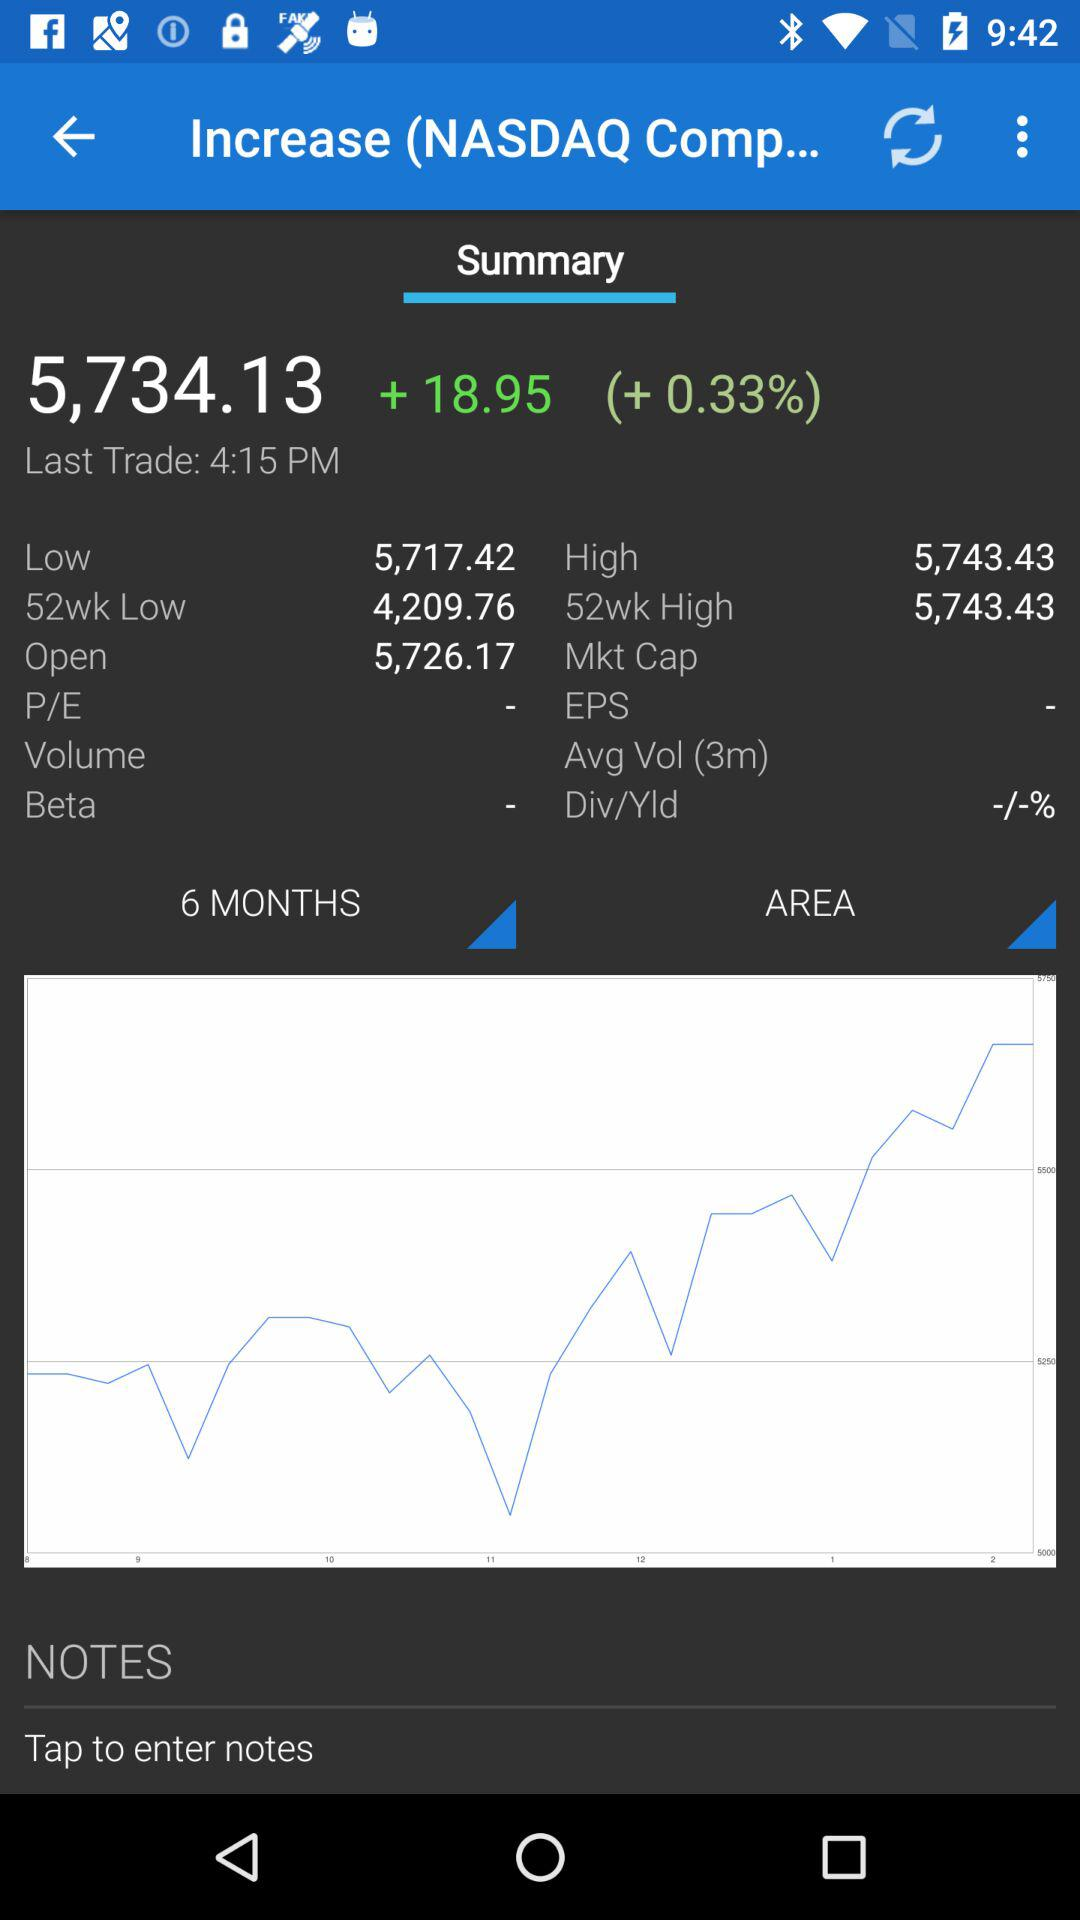What time was the last trade? The last trade was at 4:15 PM. 